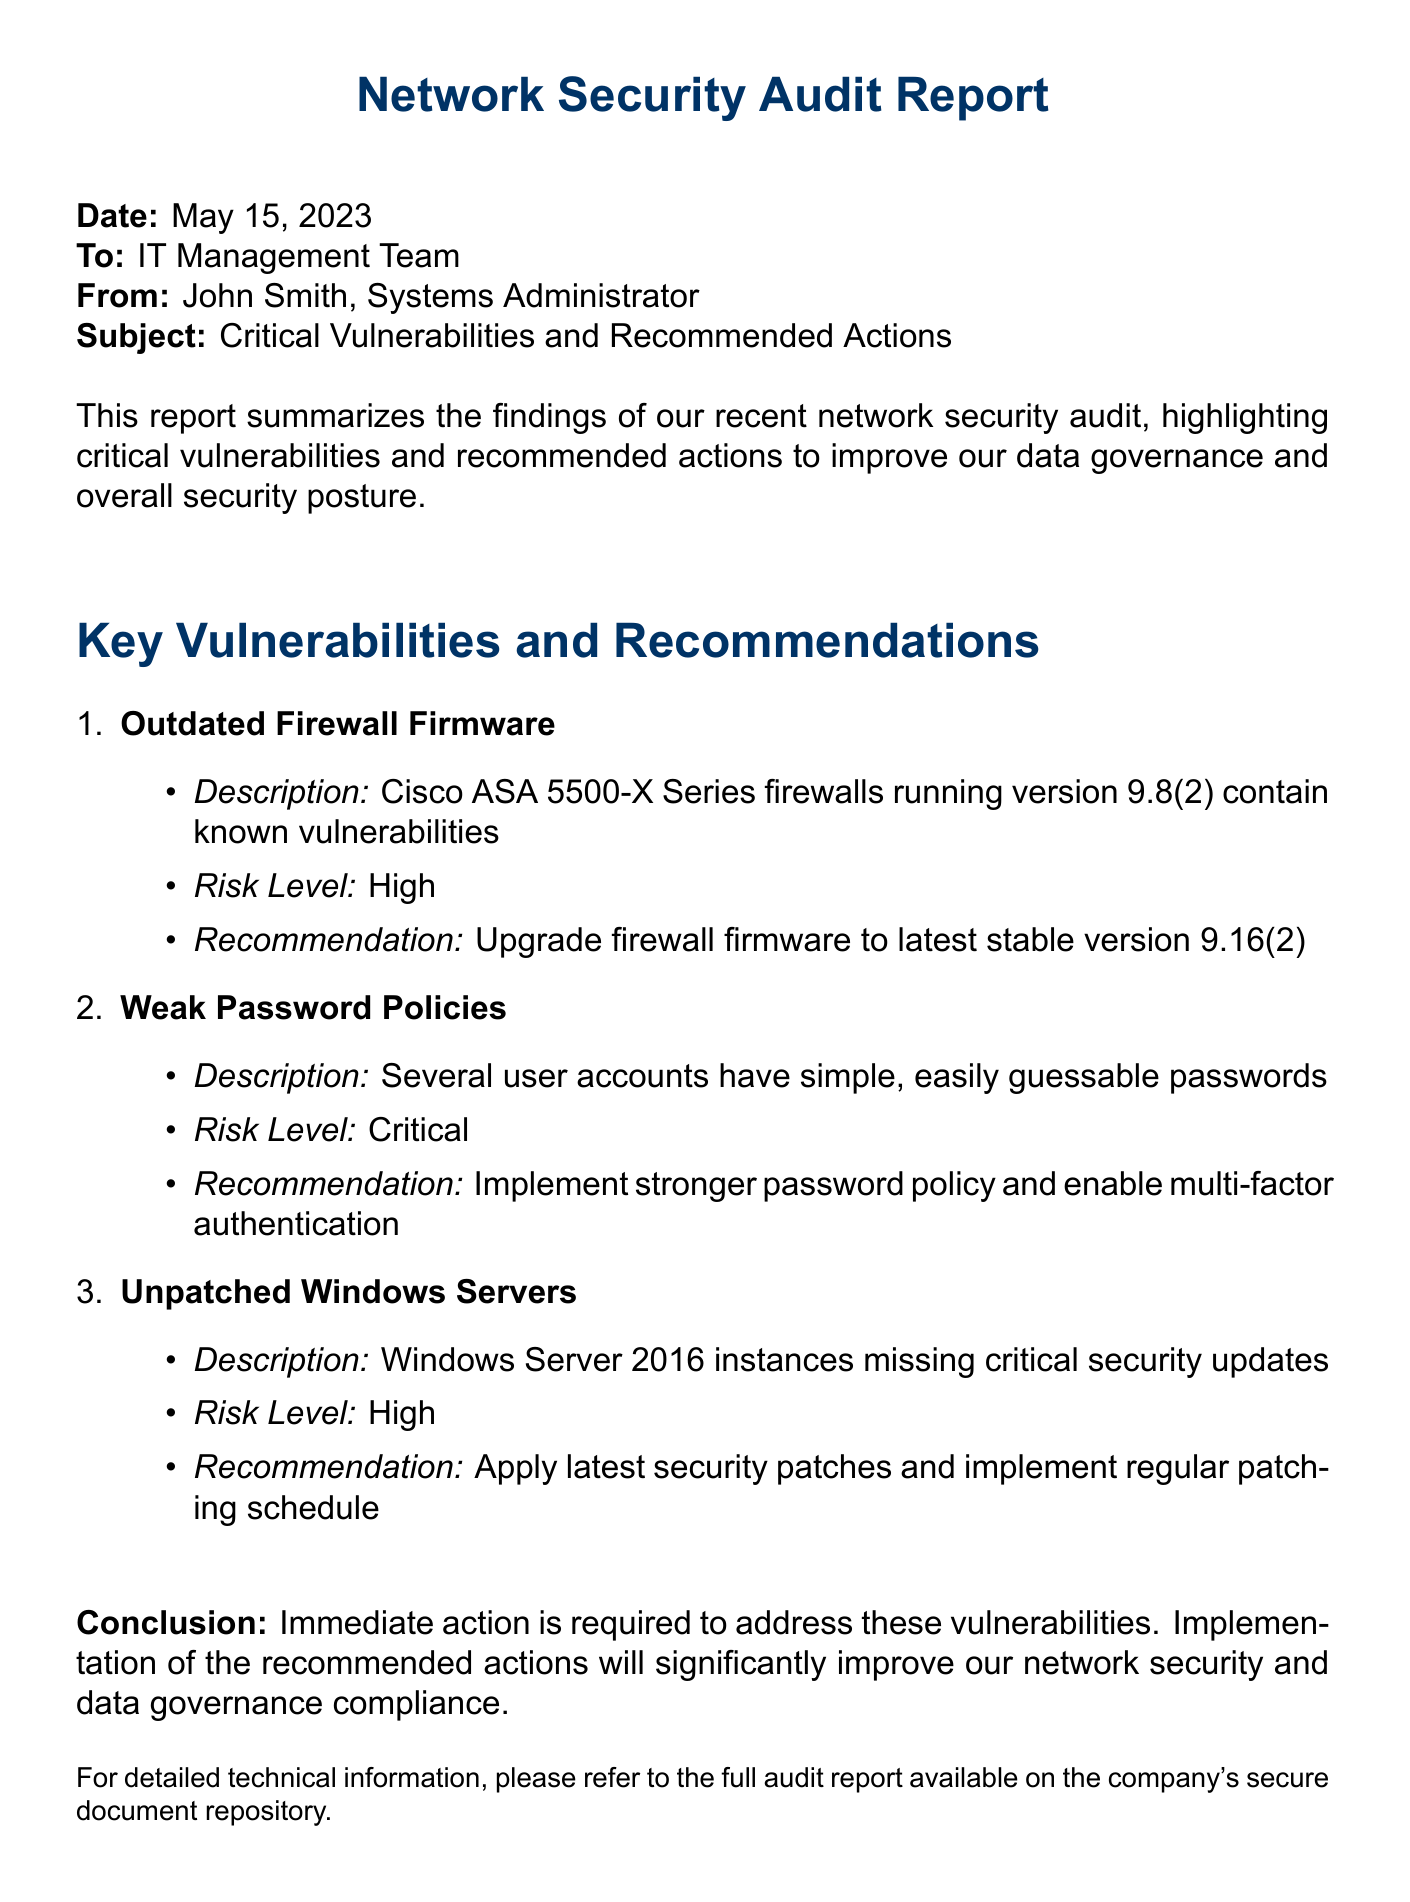What is the date of the report? The date of the report is mentioned at the beginning of the document.
Answer: May 15, 2023 Who is the author of the report? The author is indicated in the "From" section of the document.
Answer: John Smith What is the first listed vulnerability? The first vulnerability is identified in the "Key Vulnerabilities and Recommendations" section of the document.
Answer: Outdated Firewall Firmware What is the risk level associated with weak password policies? The risk level is specified under the second vulnerability listed in the report.
Answer: Critical What is the recommended action for unpatched Windows Servers? The recommended action is detailed in the corresponding section for the third vulnerability.
Answer: Apply latest security patches How many vulnerabilities are listed in the report? The total number of vulnerabilities can be counted from the enumerated list in the document.
Answer: 3 What is the highest risk level mentioned in the report? The risk levels for the vulnerabilities are categorized and the highest needs to be determined from the document.
Answer: Critical What does the conclusion state is required? The conclusion summarizes the overall recommendation from the findings of the report.
Answer: Immediate action 